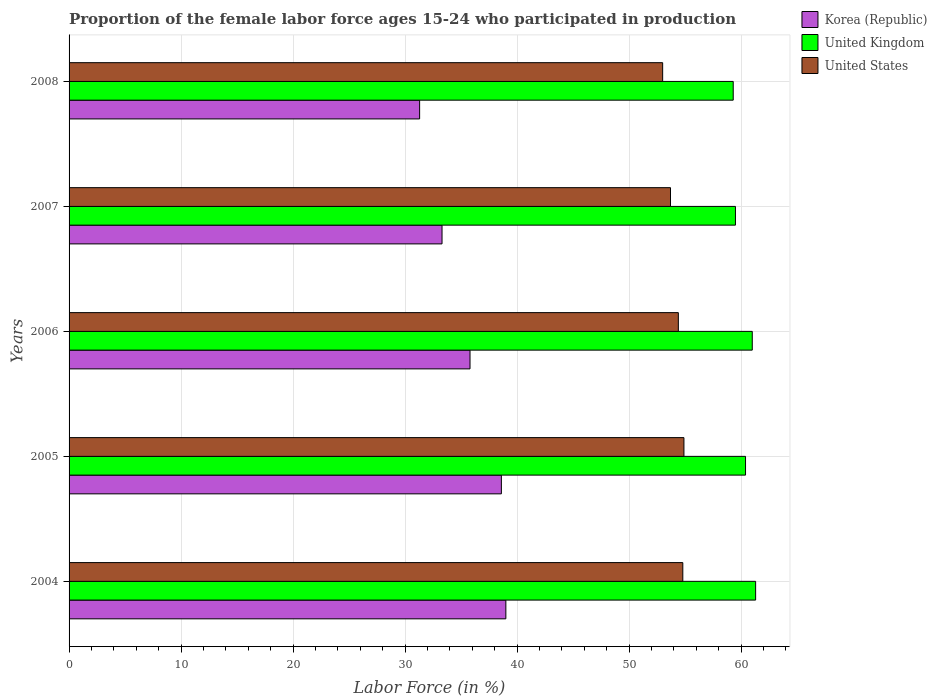Are the number of bars per tick equal to the number of legend labels?
Offer a very short reply. Yes. How many bars are there on the 4th tick from the top?
Provide a succinct answer. 3. How many bars are there on the 5th tick from the bottom?
Your answer should be very brief. 3. In how many cases, is the number of bars for a given year not equal to the number of legend labels?
Give a very brief answer. 0. What is the proportion of the female labor force who participated in production in United Kingdom in 2008?
Give a very brief answer. 59.3. Across all years, what is the maximum proportion of the female labor force who participated in production in United States?
Your answer should be very brief. 54.9. Across all years, what is the minimum proportion of the female labor force who participated in production in United Kingdom?
Provide a succinct answer. 59.3. What is the total proportion of the female labor force who participated in production in United Kingdom in the graph?
Provide a short and direct response. 301.5. What is the difference between the proportion of the female labor force who participated in production in United Kingdom in 2006 and that in 2007?
Make the answer very short. 1.5. What is the difference between the proportion of the female labor force who participated in production in United States in 2006 and the proportion of the female labor force who participated in production in Korea (Republic) in 2005?
Provide a succinct answer. 15.8. What is the average proportion of the female labor force who participated in production in Korea (Republic) per year?
Your answer should be compact. 35.6. In the year 2005, what is the difference between the proportion of the female labor force who participated in production in Korea (Republic) and proportion of the female labor force who participated in production in United States?
Your answer should be very brief. -16.3. What is the ratio of the proportion of the female labor force who participated in production in Korea (Republic) in 2006 to that in 2007?
Give a very brief answer. 1.08. Is the proportion of the female labor force who participated in production in United States in 2005 less than that in 2006?
Offer a terse response. No. Is the difference between the proportion of the female labor force who participated in production in Korea (Republic) in 2007 and 2008 greater than the difference between the proportion of the female labor force who participated in production in United States in 2007 and 2008?
Make the answer very short. Yes. What is the difference between the highest and the second highest proportion of the female labor force who participated in production in United Kingdom?
Give a very brief answer. 0.3. In how many years, is the proportion of the female labor force who participated in production in Korea (Republic) greater than the average proportion of the female labor force who participated in production in Korea (Republic) taken over all years?
Keep it short and to the point. 3. What does the 2nd bar from the bottom in 2004 represents?
Provide a short and direct response. United Kingdom. Is it the case that in every year, the sum of the proportion of the female labor force who participated in production in Korea (Republic) and proportion of the female labor force who participated in production in United Kingdom is greater than the proportion of the female labor force who participated in production in United States?
Your answer should be very brief. Yes. How many bars are there?
Offer a very short reply. 15. How many years are there in the graph?
Provide a short and direct response. 5. What is the difference between two consecutive major ticks on the X-axis?
Provide a succinct answer. 10. Where does the legend appear in the graph?
Provide a short and direct response. Top right. What is the title of the graph?
Your answer should be compact. Proportion of the female labor force ages 15-24 who participated in production. What is the label or title of the X-axis?
Keep it short and to the point. Labor Force (in %). What is the label or title of the Y-axis?
Your answer should be very brief. Years. What is the Labor Force (in %) of Korea (Republic) in 2004?
Your answer should be very brief. 39. What is the Labor Force (in %) of United Kingdom in 2004?
Provide a succinct answer. 61.3. What is the Labor Force (in %) of United States in 2004?
Your answer should be very brief. 54.8. What is the Labor Force (in %) in Korea (Republic) in 2005?
Your answer should be very brief. 38.6. What is the Labor Force (in %) in United Kingdom in 2005?
Keep it short and to the point. 60.4. What is the Labor Force (in %) in United States in 2005?
Your answer should be very brief. 54.9. What is the Labor Force (in %) of Korea (Republic) in 2006?
Your response must be concise. 35.8. What is the Labor Force (in %) in United Kingdom in 2006?
Provide a short and direct response. 61. What is the Labor Force (in %) in United States in 2006?
Keep it short and to the point. 54.4. What is the Labor Force (in %) of Korea (Republic) in 2007?
Your answer should be very brief. 33.3. What is the Labor Force (in %) in United Kingdom in 2007?
Provide a short and direct response. 59.5. What is the Labor Force (in %) of United States in 2007?
Keep it short and to the point. 53.7. What is the Labor Force (in %) of Korea (Republic) in 2008?
Provide a short and direct response. 31.3. What is the Labor Force (in %) in United Kingdom in 2008?
Your answer should be compact. 59.3. Across all years, what is the maximum Labor Force (in %) of Korea (Republic)?
Your answer should be very brief. 39. Across all years, what is the maximum Labor Force (in %) in United Kingdom?
Keep it short and to the point. 61.3. Across all years, what is the maximum Labor Force (in %) in United States?
Your answer should be very brief. 54.9. Across all years, what is the minimum Labor Force (in %) in Korea (Republic)?
Ensure brevity in your answer.  31.3. Across all years, what is the minimum Labor Force (in %) in United Kingdom?
Provide a succinct answer. 59.3. Across all years, what is the minimum Labor Force (in %) in United States?
Give a very brief answer. 53. What is the total Labor Force (in %) in Korea (Republic) in the graph?
Offer a terse response. 178. What is the total Labor Force (in %) of United Kingdom in the graph?
Your answer should be compact. 301.5. What is the total Labor Force (in %) of United States in the graph?
Give a very brief answer. 270.8. What is the difference between the Labor Force (in %) in United Kingdom in 2004 and that in 2005?
Offer a very short reply. 0.9. What is the difference between the Labor Force (in %) in United States in 2004 and that in 2005?
Make the answer very short. -0.1. What is the difference between the Labor Force (in %) of United Kingdom in 2004 and that in 2006?
Provide a short and direct response. 0.3. What is the difference between the Labor Force (in %) of United States in 2004 and that in 2006?
Your answer should be very brief. 0.4. What is the difference between the Labor Force (in %) in United Kingdom in 2004 and that in 2007?
Keep it short and to the point. 1.8. What is the difference between the Labor Force (in %) in Korea (Republic) in 2004 and that in 2008?
Make the answer very short. 7.7. What is the difference between the Labor Force (in %) in United States in 2004 and that in 2008?
Your answer should be compact. 1.8. What is the difference between the Labor Force (in %) in United Kingdom in 2005 and that in 2008?
Offer a terse response. 1.1. What is the difference between the Labor Force (in %) in United Kingdom in 2006 and that in 2007?
Provide a succinct answer. 1.5. What is the difference between the Labor Force (in %) of United Kingdom in 2006 and that in 2008?
Make the answer very short. 1.7. What is the difference between the Labor Force (in %) in Korea (Republic) in 2007 and that in 2008?
Make the answer very short. 2. What is the difference between the Labor Force (in %) in United Kingdom in 2007 and that in 2008?
Your answer should be very brief. 0.2. What is the difference between the Labor Force (in %) of United States in 2007 and that in 2008?
Offer a very short reply. 0.7. What is the difference between the Labor Force (in %) in Korea (Republic) in 2004 and the Labor Force (in %) in United Kingdom in 2005?
Make the answer very short. -21.4. What is the difference between the Labor Force (in %) of Korea (Republic) in 2004 and the Labor Force (in %) of United States in 2005?
Make the answer very short. -15.9. What is the difference between the Labor Force (in %) in United Kingdom in 2004 and the Labor Force (in %) in United States in 2005?
Provide a succinct answer. 6.4. What is the difference between the Labor Force (in %) of Korea (Republic) in 2004 and the Labor Force (in %) of United States in 2006?
Offer a terse response. -15.4. What is the difference between the Labor Force (in %) of Korea (Republic) in 2004 and the Labor Force (in %) of United Kingdom in 2007?
Keep it short and to the point. -20.5. What is the difference between the Labor Force (in %) in Korea (Republic) in 2004 and the Labor Force (in %) in United States in 2007?
Offer a very short reply. -14.7. What is the difference between the Labor Force (in %) in United Kingdom in 2004 and the Labor Force (in %) in United States in 2007?
Your response must be concise. 7.6. What is the difference between the Labor Force (in %) in Korea (Republic) in 2004 and the Labor Force (in %) in United Kingdom in 2008?
Keep it short and to the point. -20.3. What is the difference between the Labor Force (in %) of United Kingdom in 2004 and the Labor Force (in %) of United States in 2008?
Ensure brevity in your answer.  8.3. What is the difference between the Labor Force (in %) in Korea (Republic) in 2005 and the Labor Force (in %) in United Kingdom in 2006?
Provide a short and direct response. -22.4. What is the difference between the Labor Force (in %) in Korea (Republic) in 2005 and the Labor Force (in %) in United States in 2006?
Your response must be concise. -15.8. What is the difference between the Labor Force (in %) in United Kingdom in 2005 and the Labor Force (in %) in United States in 2006?
Provide a succinct answer. 6. What is the difference between the Labor Force (in %) in Korea (Republic) in 2005 and the Labor Force (in %) in United Kingdom in 2007?
Keep it short and to the point. -20.9. What is the difference between the Labor Force (in %) of Korea (Republic) in 2005 and the Labor Force (in %) of United States in 2007?
Your answer should be compact. -15.1. What is the difference between the Labor Force (in %) of United Kingdom in 2005 and the Labor Force (in %) of United States in 2007?
Keep it short and to the point. 6.7. What is the difference between the Labor Force (in %) in Korea (Republic) in 2005 and the Labor Force (in %) in United Kingdom in 2008?
Give a very brief answer. -20.7. What is the difference between the Labor Force (in %) in Korea (Republic) in 2005 and the Labor Force (in %) in United States in 2008?
Your answer should be very brief. -14.4. What is the difference between the Labor Force (in %) in United Kingdom in 2005 and the Labor Force (in %) in United States in 2008?
Make the answer very short. 7.4. What is the difference between the Labor Force (in %) in Korea (Republic) in 2006 and the Labor Force (in %) in United Kingdom in 2007?
Offer a terse response. -23.7. What is the difference between the Labor Force (in %) in Korea (Republic) in 2006 and the Labor Force (in %) in United States in 2007?
Offer a very short reply. -17.9. What is the difference between the Labor Force (in %) in Korea (Republic) in 2006 and the Labor Force (in %) in United Kingdom in 2008?
Your response must be concise. -23.5. What is the difference between the Labor Force (in %) in Korea (Republic) in 2006 and the Labor Force (in %) in United States in 2008?
Your answer should be compact. -17.2. What is the difference between the Labor Force (in %) in Korea (Republic) in 2007 and the Labor Force (in %) in United Kingdom in 2008?
Your answer should be compact. -26. What is the difference between the Labor Force (in %) in Korea (Republic) in 2007 and the Labor Force (in %) in United States in 2008?
Make the answer very short. -19.7. What is the difference between the Labor Force (in %) of United Kingdom in 2007 and the Labor Force (in %) of United States in 2008?
Make the answer very short. 6.5. What is the average Labor Force (in %) of Korea (Republic) per year?
Your answer should be compact. 35.6. What is the average Labor Force (in %) in United Kingdom per year?
Offer a very short reply. 60.3. What is the average Labor Force (in %) of United States per year?
Your response must be concise. 54.16. In the year 2004, what is the difference between the Labor Force (in %) of Korea (Republic) and Labor Force (in %) of United Kingdom?
Your response must be concise. -22.3. In the year 2004, what is the difference between the Labor Force (in %) in Korea (Republic) and Labor Force (in %) in United States?
Offer a very short reply. -15.8. In the year 2004, what is the difference between the Labor Force (in %) in United Kingdom and Labor Force (in %) in United States?
Provide a short and direct response. 6.5. In the year 2005, what is the difference between the Labor Force (in %) in Korea (Republic) and Labor Force (in %) in United Kingdom?
Offer a very short reply. -21.8. In the year 2005, what is the difference between the Labor Force (in %) of Korea (Republic) and Labor Force (in %) of United States?
Provide a succinct answer. -16.3. In the year 2006, what is the difference between the Labor Force (in %) of Korea (Republic) and Labor Force (in %) of United Kingdom?
Your answer should be compact. -25.2. In the year 2006, what is the difference between the Labor Force (in %) of Korea (Republic) and Labor Force (in %) of United States?
Keep it short and to the point. -18.6. In the year 2007, what is the difference between the Labor Force (in %) of Korea (Republic) and Labor Force (in %) of United Kingdom?
Offer a very short reply. -26.2. In the year 2007, what is the difference between the Labor Force (in %) of Korea (Republic) and Labor Force (in %) of United States?
Provide a succinct answer. -20.4. In the year 2007, what is the difference between the Labor Force (in %) in United Kingdom and Labor Force (in %) in United States?
Offer a terse response. 5.8. In the year 2008, what is the difference between the Labor Force (in %) of Korea (Republic) and Labor Force (in %) of United States?
Offer a terse response. -21.7. In the year 2008, what is the difference between the Labor Force (in %) of United Kingdom and Labor Force (in %) of United States?
Provide a succinct answer. 6.3. What is the ratio of the Labor Force (in %) in Korea (Republic) in 2004 to that in 2005?
Offer a terse response. 1.01. What is the ratio of the Labor Force (in %) of United Kingdom in 2004 to that in 2005?
Your answer should be compact. 1.01. What is the ratio of the Labor Force (in %) of Korea (Republic) in 2004 to that in 2006?
Make the answer very short. 1.09. What is the ratio of the Labor Force (in %) in United Kingdom in 2004 to that in 2006?
Make the answer very short. 1. What is the ratio of the Labor Force (in %) of United States in 2004 to that in 2006?
Offer a terse response. 1.01. What is the ratio of the Labor Force (in %) in Korea (Republic) in 2004 to that in 2007?
Provide a succinct answer. 1.17. What is the ratio of the Labor Force (in %) in United Kingdom in 2004 to that in 2007?
Provide a succinct answer. 1.03. What is the ratio of the Labor Force (in %) in United States in 2004 to that in 2007?
Give a very brief answer. 1.02. What is the ratio of the Labor Force (in %) of Korea (Republic) in 2004 to that in 2008?
Make the answer very short. 1.25. What is the ratio of the Labor Force (in %) of United Kingdom in 2004 to that in 2008?
Give a very brief answer. 1.03. What is the ratio of the Labor Force (in %) of United States in 2004 to that in 2008?
Provide a short and direct response. 1.03. What is the ratio of the Labor Force (in %) of Korea (Republic) in 2005 to that in 2006?
Give a very brief answer. 1.08. What is the ratio of the Labor Force (in %) of United Kingdom in 2005 to that in 2006?
Keep it short and to the point. 0.99. What is the ratio of the Labor Force (in %) in United States in 2005 to that in 2006?
Provide a short and direct response. 1.01. What is the ratio of the Labor Force (in %) of Korea (Republic) in 2005 to that in 2007?
Ensure brevity in your answer.  1.16. What is the ratio of the Labor Force (in %) of United Kingdom in 2005 to that in 2007?
Your answer should be very brief. 1.02. What is the ratio of the Labor Force (in %) of United States in 2005 to that in 2007?
Give a very brief answer. 1.02. What is the ratio of the Labor Force (in %) in Korea (Republic) in 2005 to that in 2008?
Provide a succinct answer. 1.23. What is the ratio of the Labor Force (in %) in United Kingdom in 2005 to that in 2008?
Offer a terse response. 1.02. What is the ratio of the Labor Force (in %) of United States in 2005 to that in 2008?
Your answer should be very brief. 1.04. What is the ratio of the Labor Force (in %) of Korea (Republic) in 2006 to that in 2007?
Your answer should be compact. 1.08. What is the ratio of the Labor Force (in %) of United Kingdom in 2006 to that in 2007?
Give a very brief answer. 1.03. What is the ratio of the Labor Force (in %) in Korea (Republic) in 2006 to that in 2008?
Provide a succinct answer. 1.14. What is the ratio of the Labor Force (in %) in United Kingdom in 2006 to that in 2008?
Your answer should be very brief. 1.03. What is the ratio of the Labor Force (in %) of United States in 2006 to that in 2008?
Ensure brevity in your answer.  1.03. What is the ratio of the Labor Force (in %) of Korea (Republic) in 2007 to that in 2008?
Your answer should be very brief. 1.06. What is the ratio of the Labor Force (in %) in United States in 2007 to that in 2008?
Your answer should be compact. 1.01. What is the difference between the highest and the second highest Labor Force (in %) of Korea (Republic)?
Keep it short and to the point. 0.4. What is the difference between the highest and the second highest Labor Force (in %) of United States?
Make the answer very short. 0.1. What is the difference between the highest and the lowest Labor Force (in %) of United States?
Provide a short and direct response. 1.9. 